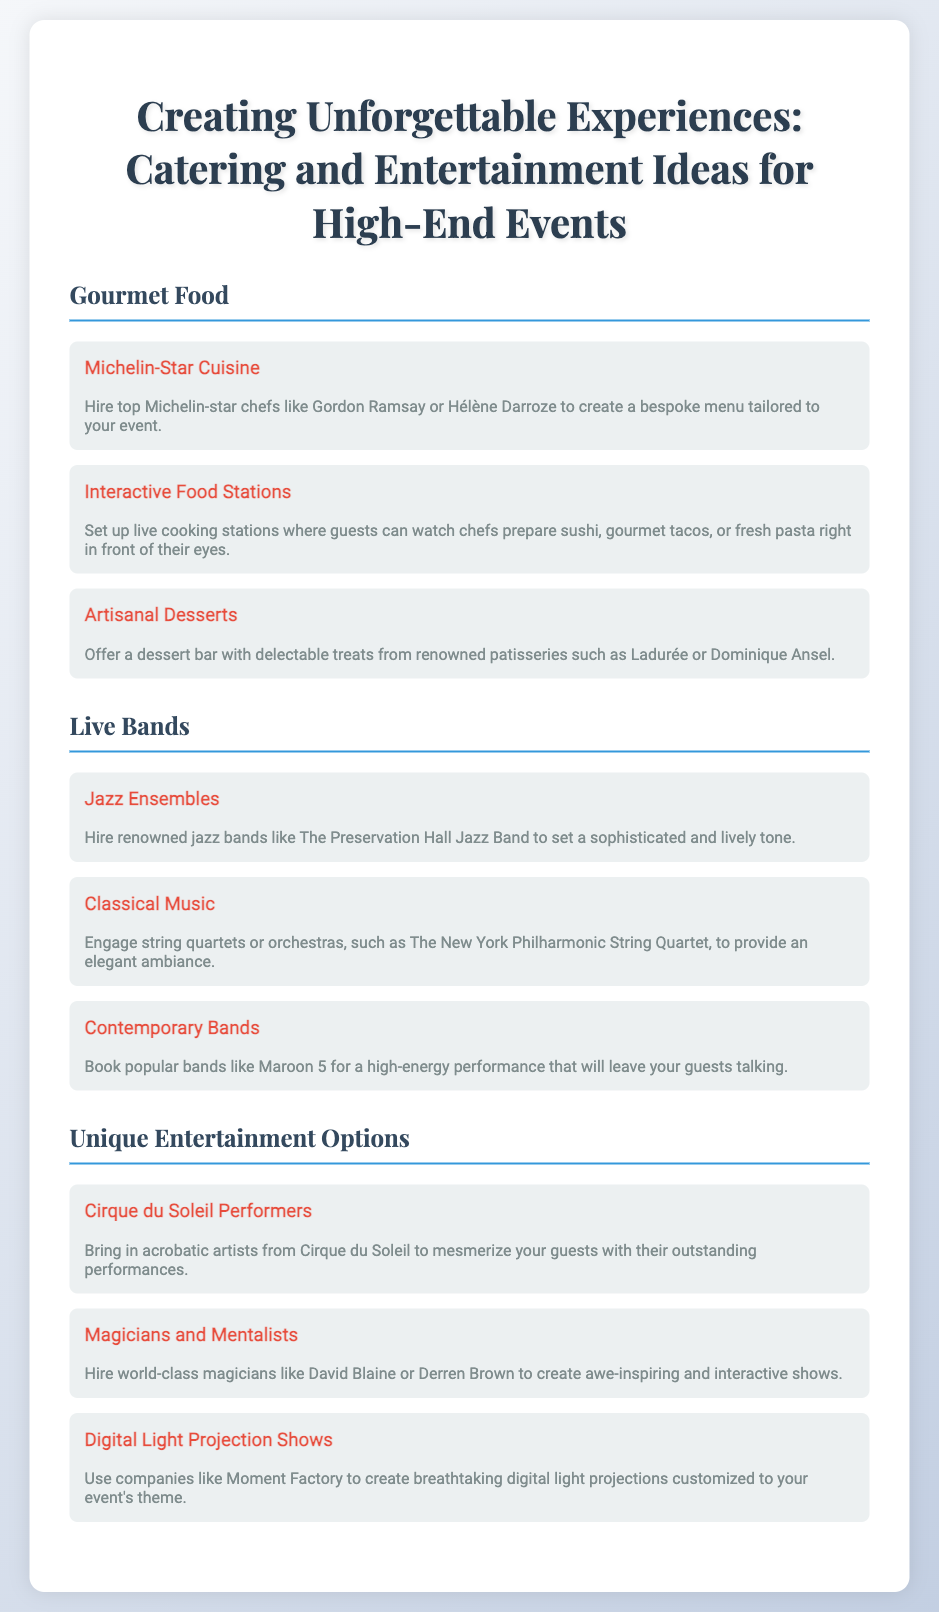What is the title of the poster? The title of the poster is stated prominently at the top, which introduces the main theme of the document.
Answer: Creating Unforgettable Experiences: Catering and Entertainment Ideas for High-End Events Who is a suggested chef for Michelin-Star Cuisine? The document mentions a renowned chef in the context of providing high-end catering options for the events.
Answer: Gordon Ramsay What type of musicians can provide a sophisticated tone? This question refers to the live bands section where specific types of bands are highlighted.
Answer: Jazz Ensembles What unique entertainment option involves acrobatic artists? The document specifically lists unique entertainment acts, and acrobatic artists are featured in one of the sections.
Answer: Cirque du Soleil Performers Which band is suggested for a high-energy performance? This refers to popular bands mentioned in the live bands section that can energize the event atmosphere.
Answer: Maroon 5 How many unique entertainment options are listed? The document lists various unique entertainment options, requiring a count of them mentioned in the section.
Answer: Three 